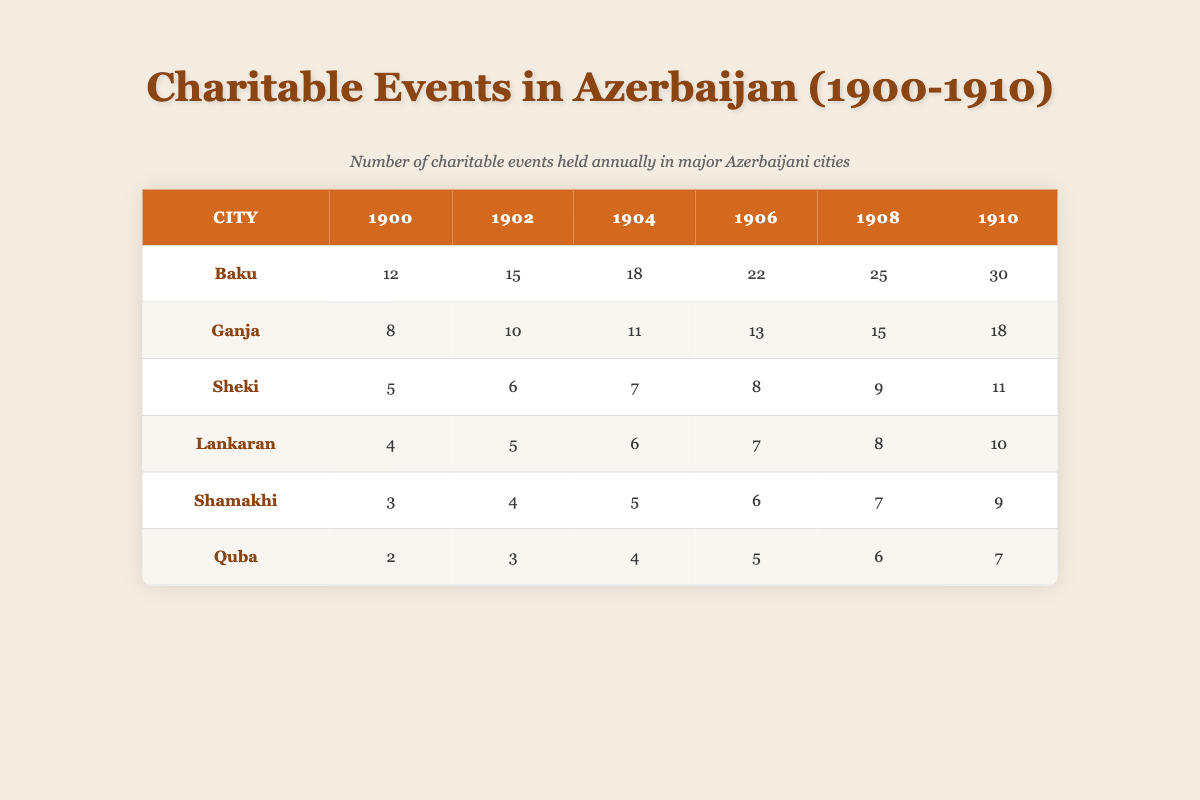What city had the highest number of charitable events in 1910? Looking at the row for the year 1910, Baku has the highest number of charitable events, which is 30.
Answer: Baku How many charitable events were held in Ganja in 1904? The table shows that Ganja held 11 charitable events in the year 1904.
Answer: 11 Which city showed the highest overall growth in the number of charitable events from 1900 to 1910? To find the overall growth, we subtract the number of events in 1900 from the total in 1910 for each city. For Baku, it’s 30-12=18; Ganja is 18-8=10; Sheki is 11-5=6; Lankaran is 10-4=6; Shamakhi is 9-3=6; Quba is 7-2=5. Baku had the highest growth of 18 events.
Answer: Baku Were there more charitable events held in Sheki than in Shamakhi in 1908? In 1908, Sheki held 9 events, while Shamakhi held 7 events. Since 9 is greater than 7, it is true that Sheki had more events than Shamakhi.
Answer: Yes What is the average number of charitable events held in Lankaran over the years 1900 to 1910? To calculate the average, we sum the number of events: 4 + 5 + 6 + 7 + 8 + 10 = 40. Then divide by the number of data points, which is 6. Therefore, 40/6 = 6.67.
Answer: 6.67 In which year did Quba see the least number of charitable events? Checking the row for Quba, the yearly events are 2, 3, 4, 5, 6, and 7. The least number occurred in 1900, which is 2.
Answer: 1900 Which city consistently had the lowest number of charitable events throughout the years? By reviewing each year's data, Quba consistently has the lowest numbers: 2, 3, 4, 5, 6, and 7. Therefore, Quba had the lowest numbers each year analyzed.
Answer: Quba What was the total number of charitable events held in Baku from 1900 to 1910? We sum the events for Baku across all relevant years: 12 + 15 + 18 + 22 + 25 + 30 = 122.
Answer: 122 How many more events did Baku host in 1906 compared to Sheki? In 1906, Baku hosted 22 events and Sheki hosted 8. Subtracting these values, we have 22 - 8 = 14, meaning Baku hosted 14 more events than Sheki in 1906.
Answer: 14 